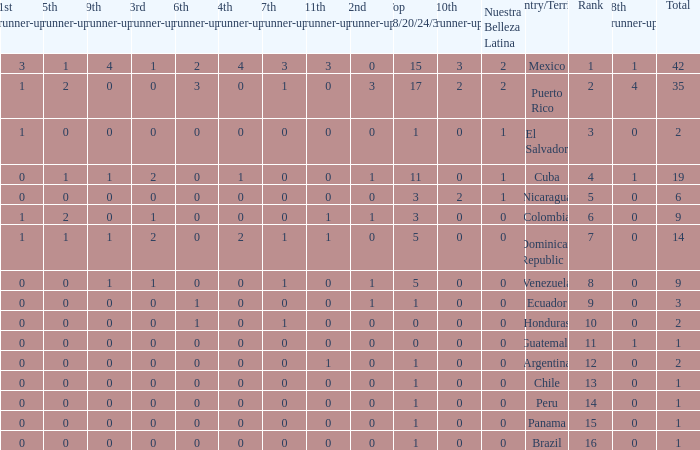What is the 3rd runner-up of the country with more than 0 9th runner-up, an 11th runner-up of 0, and the 1st runner-up greater than 0? None. 